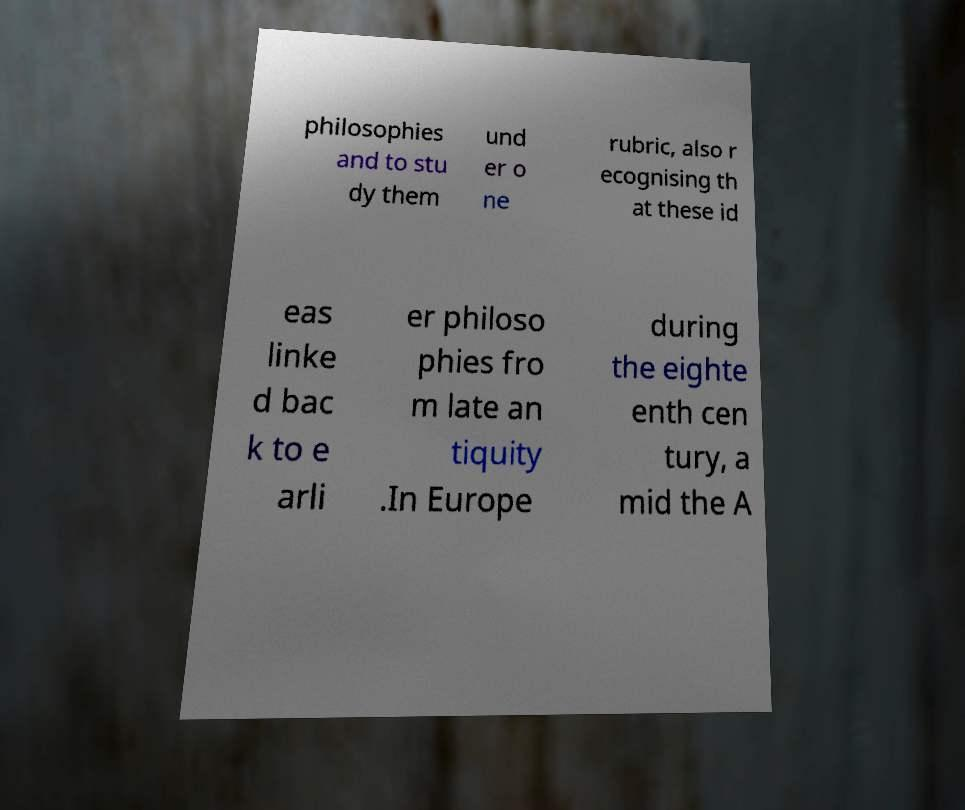Can you read and provide the text displayed in the image?This photo seems to have some interesting text. Can you extract and type it out for me? philosophies and to stu dy them und er o ne rubric, also r ecognising th at these id eas linke d bac k to e arli er philoso phies fro m late an tiquity .In Europe during the eighte enth cen tury, a mid the A 